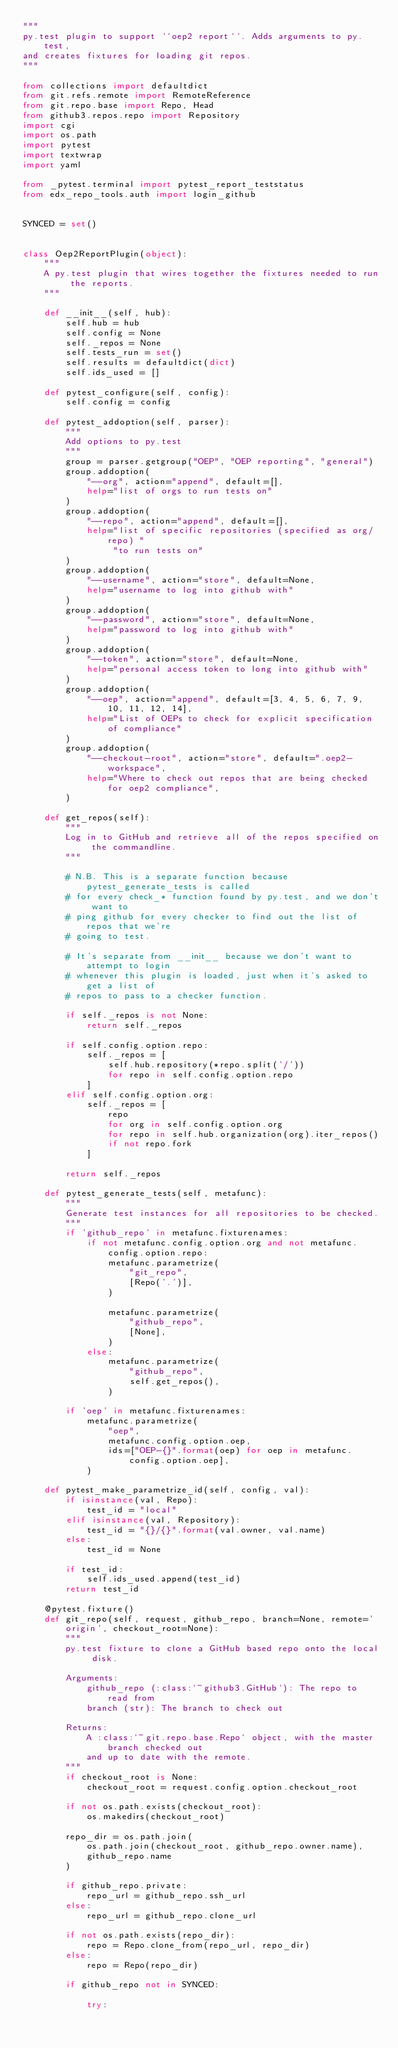Convert code to text. <code><loc_0><loc_0><loc_500><loc_500><_Python_>"""
py.test plugin to support ``oep2 report``. Adds arguments to py.test,
and creates fixtures for loading git repos.
"""

from collections import defaultdict
from git.refs.remote import RemoteReference
from git.repo.base import Repo, Head
from github3.repos.repo import Repository
import cgi
import os.path
import pytest
import textwrap
import yaml

from _pytest.terminal import pytest_report_teststatus
from edx_repo_tools.auth import login_github


SYNCED = set()


class Oep2ReportPlugin(object):
    """
    A py.test plugin that wires together the fixtures needed to run the reports.
    """

    def __init__(self, hub):
        self.hub = hub
        self.config = None
        self._repos = None
        self.tests_run = set()
        self.results = defaultdict(dict)
        self.ids_used = []

    def pytest_configure(self, config):
        self.config = config

    def pytest_addoption(self, parser):
        """
        Add options to py.test
        """
        group = parser.getgroup("OEP", "OEP reporting", "general")
        group.addoption(
            "--org", action="append", default=[],
            help="list of orgs to run tests on"
        )
        group.addoption(
            "--repo", action="append", default=[],
            help="list of specific repositories (specified as org/repo) "
                 "to run tests on"
        )
        group.addoption(
            "--username", action="store", default=None,
            help="username to log into github with"
        )
        group.addoption(
            "--password", action="store", default=None,
            help="password to log into github with"
        )
        group.addoption(
            "--token", action="store", default=None,
            help="personal access token to long into github with"
        )
        group.addoption(
            "--oep", action="append", default=[3, 4, 5, 6, 7, 9, 10, 11, 12, 14],
            help="List of OEPs to check for explicit specification of compliance"
        )
        group.addoption(
            "--checkout-root", action="store", default=".oep2-workspace",
            help="Where to check out repos that are being checked for oep2 compliance",
        )

    def get_repos(self):
        """
        Log in to GitHub and retrieve all of the repos specified on the commandline.
        """

        # N.B. This is a separate function because pytest_generate_tests is called
        # for every check_* function found by py.test, and we don't want to
        # ping github for every checker to find out the list of repos that we're
        # going to test.

        # It's separate from __init__ because we don't want to attempt to login
        # whenever this plugin is loaded, just when it's asked to get a list of
        # repos to pass to a checker function.

        if self._repos is not None:
            return self._repos

        if self.config.option.repo:
            self._repos = [
                self.hub.repository(*repo.split('/'))
                for repo in self.config.option.repo
            ]
        elif self.config.option.org:
            self._repos = [
                repo
                for org in self.config.option.org
                for repo in self.hub.organization(org).iter_repos()
                if not repo.fork
            ]

        return self._repos

    def pytest_generate_tests(self, metafunc):
        """
        Generate test instances for all repositories to be checked.
        """
        if 'github_repo' in metafunc.fixturenames:
            if not metafunc.config.option.org and not metafunc.config.option.repo:
                metafunc.parametrize(
                    "git_repo",
                    [Repo('.')],
                )

                metafunc.parametrize(
                    "github_repo",
                    [None],
                )
            else:
                metafunc.parametrize(
                    "github_repo",
                    self.get_repos(),
                )

        if 'oep' in metafunc.fixturenames:
            metafunc.parametrize(
                "oep",
                metafunc.config.option.oep,
                ids=["OEP-{}".format(oep) for oep in metafunc.config.option.oep],
            )

    def pytest_make_parametrize_id(self, config, val):
        if isinstance(val, Repo):
            test_id = "local"
        elif isinstance(val, Repository):
            test_id = "{}/{}".format(val.owner, val.name)
        else:
            test_id = None

        if test_id:
            self.ids_used.append(test_id)
        return test_id

    @pytest.fixture()
    def git_repo(self, request, github_repo, branch=None, remote='origin', checkout_root=None):
        """
        py.test fixture to clone a GitHub based repo onto the local disk.

        Arguments:
            github_repo (:class:`~github3.GitHub`): The repo to read from
            branch (str): The branch to check out

        Returns:
            A :class:`~git.repo.base.Repo` object, with the master branch checked out
            and up to date with the remote.
        """
        if checkout_root is None:
            checkout_root = request.config.option.checkout_root

        if not os.path.exists(checkout_root):
            os.makedirs(checkout_root)

        repo_dir = os.path.join(
            os.path.join(checkout_root, github_repo.owner.name),
            github_repo.name
        )

        if github_repo.private:
            repo_url = github_repo.ssh_url
        else:
            repo_url = github_repo.clone_url

        if not os.path.exists(repo_dir):
            repo = Repo.clone_from(repo_url, repo_dir)
        else:
            repo = Repo(repo_dir)

        if github_repo not in SYNCED:

            try:</code> 